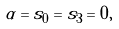Convert formula to latex. <formula><loc_0><loc_0><loc_500><loc_500>\alpha = s _ { 0 } = s _ { 3 } = 0 ,</formula> 